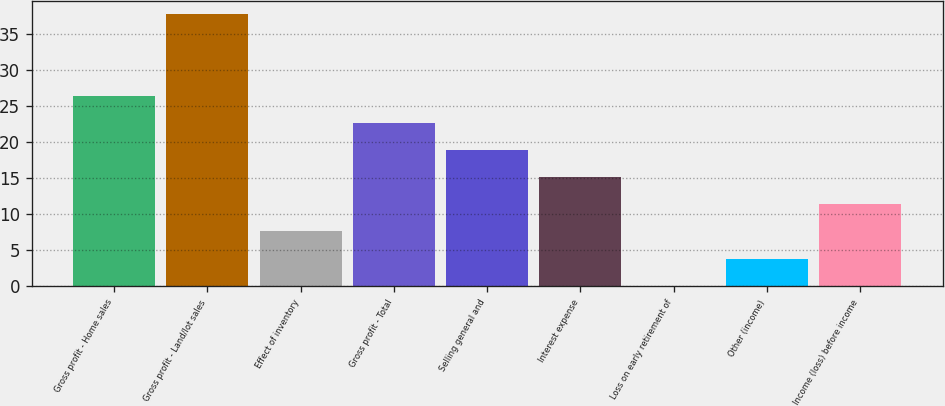Convert chart to OTSL. <chart><loc_0><loc_0><loc_500><loc_500><bar_chart><fcel>Gross profit - Home sales<fcel>Gross profit - Land/lot sales<fcel>Effect of inventory<fcel>Gross profit - Total<fcel>Selling general and<fcel>Interest expense<fcel>Loss on early retirement of<fcel>Other (income)<fcel>Income (loss) before income<nl><fcel>26.49<fcel>37.8<fcel>7.64<fcel>22.72<fcel>18.95<fcel>15.18<fcel>0.1<fcel>3.87<fcel>11.41<nl></chart> 